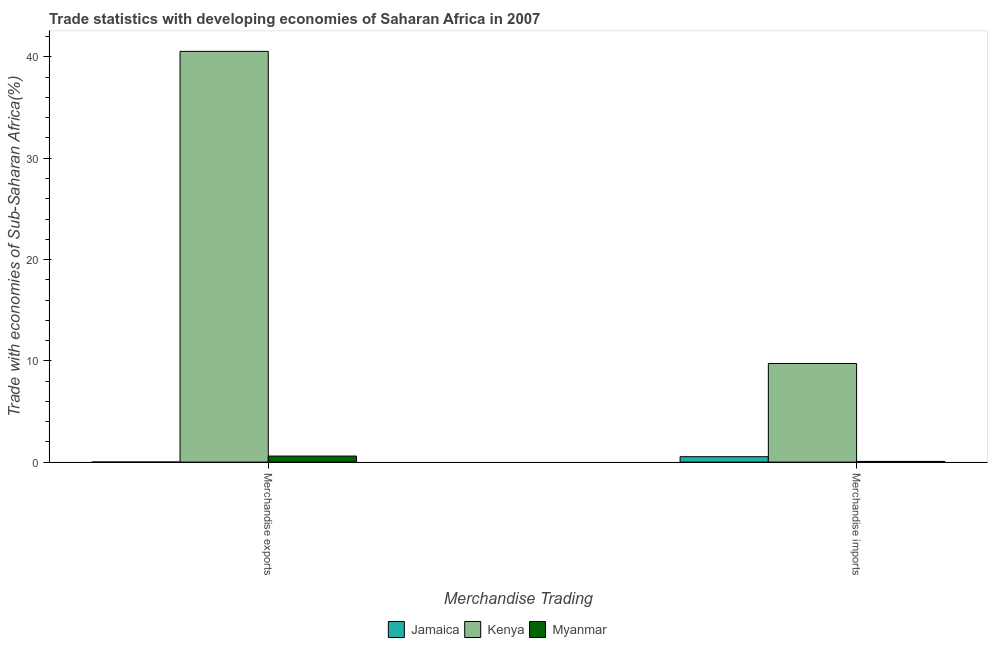How many different coloured bars are there?
Make the answer very short. 3. Are the number of bars per tick equal to the number of legend labels?
Your answer should be very brief. Yes. Are the number of bars on each tick of the X-axis equal?
Offer a very short reply. Yes. How many bars are there on the 1st tick from the left?
Your answer should be compact. 3. How many bars are there on the 1st tick from the right?
Make the answer very short. 3. What is the merchandise imports in Kenya?
Keep it short and to the point. 9.73. Across all countries, what is the maximum merchandise imports?
Offer a terse response. 9.73. Across all countries, what is the minimum merchandise imports?
Provide a succinct answer. 0.07. In which country was the merchandise exports maximum?
Keep it short and to the point. Kenya. In which country was the merchandise imports minimum?
Your response must be concise. Myanmar. What is the total merchandise imports in the graph?
Offer a very short reply. 10.34. What is the difference between the merchandise exports in Kenya and that in Jamaica?
Keep it short and to the point. 40.54. What is the difference between the merchandise exports in Myanmar and the merchandise imports in Jamaica?
Keep it short and to the point. 0.06. What is the average merchandise exports per country?
Keep it short and to the point. 13.72. What is the difference between the merchandise exports and merchandise imports in Jamaica?
Your response must be concise. -0.53. What is the ratio of the merchandise exports in Myanmar to that in Kenya?
Provide a short and direct response. 0.01. Is the merchandise exports in Kenya less than that in Jamaica?
Give a very brief answer. No. In how many countries, is the merchandise imports greater than the average merchandise imports taken over all countries?
Offer a very short reply. 1. What does the 1st bar from the left in Merchandise imports represents?
Provide a succinct answer. Jamaica. What does the 2nd bar from the right in Merchandise exports represents?
Provide a short and direct response. Kenya. Are the values on the major ticks of Y-axis written in scientific E-notation?
Your response must be concise. No. Does the graph contain any zero values?
Your answer should be very brief. No. Does the graph contain grids?
Your response must be concise. No. Where does the legend appear in the graph?
Offer a terse response. Bottom center. What is the title of the graph?
Your answer should be very brief. Trade statistics with developing economies of Saharan Africa in 2007. What is the label or title of the X-axis?
Your answer should be compact. Merchandise Trading. What is the label or title of the Y-axis?
Your response must be concise. Trade with economies of Sub-Saharan Africa(%). What is the Trade with economies of Sub-Saharan Africa(%) of Jamaica in Merchandise exports?
Keep it short and to the point. 0.01. What is the Trade with economies of Sub-Saharan Africa(%) of Kenya in Merchandise exports?
Offer a very short reply. 40.55. What is the Trade with economies of Sub-Saharan Africa(%) in Myanmar in Merchandise exports?
Offer a terse response. 0.6. What is the Trade with economies of Sub-Saharan Africa(%) in Jamaica in Merchandise imports?
Give a very brief answer. 0.54. What is the Trade with economies of Sub-Saharan Africa(%) in Kenya in Merchandise imports?
Offer a terse response. 9.73. What is the Trade with economies of Sub-Saharan Africa(%) of Myanmar in Merchandise imports?
Offer a very short reply. 0.07. Across all Merchandise Trading, what is the maximum Trade with economies of Sub-Saharan Africa(%) in Jamaica?
Give a very brief answer. 0.54. Across all Merchandise Trading, what is the maximum Trade with economies of Sub-Saharan Africa(%) of Kenya?
Your answer should be compact. 40.55. Across all Merchandise Trading, what is the maximum Trade with economies of Sub-Saharan Africa(%) in Myanmar?
Offer a terse response. 0.6. Across all Merchandise Trading, what is the minimum Trade with economies of Sub-Saharan Africa(%) in Jamaica?
Keep it short and to the point. 0.01. Across all Merchandise Trading, what is the minimum Trade with economies of Sub-Saharan Africa(%) in Kenya?
Provide a succinct answer. 9.73. Across all Merchandise Trading, what is the minimum Trade with economies of Sub-Saharan Africa(%) of Myanmar?
Provide a short and direct response. 0.07. What is the total Trade with economies of Sub-Saharan Africa(%) of Jamaica in the graph?
Make the answer very short. 0.54. What is the total Trade with economies of Sub-Saharan Africa(%) of Kenya in the graph?
Your answer should be compact. 50.28. What is the total Trade with economies of Sub-Saharan Africa(%) of Myanmar in the graph?
Your answer should be very brief. 0.67. What is the difference between the Trade with economies of Sub-Saharan Africa(%) of Jamaica in Merchandise exports and that in Merchandise imports?
Your response must be concise. -0.53. What is the difference between the Trade with economies of Sub-Saharan Africa(%) of Kenya in Merchandise exports and that in Merchandise imports?
Offer a terse response. 30.82. What is the difference between the Trade with economies of Sub-Saharan Africa(%) of Myanmar in Merchandise exports and that in Merchandise imports?
Your answer should be compact. 0.53. What is the difference between the Trade with economies of Sub-Saharan Africa(%) in Jamaica in Merchandise exports and the Trade with economies of Sub-Saharan Africa(%) in Kenya in Merchandise imports?
Offer a very short reply. -9.72. What is the difference between the Trade with economies of Sub-Saharan Africa(%) in Jamaica in Merchandise exports and the Trade with economies of Sub-Saharan Africa(%) in Myanmar in Merchandise imports?
Provide a succinct answer. -0.06. What is the difference between the Trade with economies of Sub-Saharan Africa(%) of Kenya in Merchandise exports and the Trade with economies of Sub-Saharan Africa(%) of Myanmar in Merchandise imports?
Ensure brevity in your answer.  40.48. What is the average Trade with economies of Sub-Saharan Africa(%) in Jamaica per Merchandise Trading?
Give a very brief answer. 0.27. What is the average Trade with economies of Sub-Saharan Africa(%) of Kenya per Merchandise Trading?
Your response must be concise. 25.14. What is the average Trade with economies of Sub-Saharan Africa(%) in Myanmar per Merchandise Trading?
Provide a succinct answer. 0.33. What is the difference between the Trade with economies of Sub-Saharan Africa(%) in Jamaica and Trade with economies of Sub-Saharan Africa(%) in Kenya in Merchandise exports?
Keep it short and to the point. -40.54. What is the difference between the Trade with economies of Sub-Saharan Africa(%) of Jamaica and Trade with economies of Sub-Saharan Africa(%) of Myanmar in Merchandise exports?
Your response must be concise. -0.59. What is the difference between the Trade with economies of Sub-Saharan Africa(%) in Kenya and Trade with economies of Sub-Saharan Africa(%) in Myanmar in Merchandise exports?
Your response must be concise. 39.95. What is the difference between the Trade with economies of Sub-Saharan Africa(%) of Jamaica and Trade with economies of Sub-Saharan Africa(%) of Kenya in Merchandise imports?
Provide a succinct answer. -9.2. What is the difference between the Trade with economies of Sub-Saharan Africa(%) in Jamaica and Trade with economies of Sub-Saharan Africa(%) in Myanmar in Merchandise imports?
Provide a succinct answer. 0.46. What is the difference between the Trade with economies of Sub-Saharan Africa(%) in Kenya and Trade with economies of Sub-Saharan Africa(%) in Myanmar in Merchandise imports?
Give a very brief answer. 9.66. What is the ratio of the Trade with economies of Sub-Saharan Africa(%) in Jamaica in Merchandise exports to that in Merchandise imports?
Ensure brevity in your answer.  0.02. What is the ratio of the Trade with economies of Sub-Saharan Africa(%) of Kenya in Merchandise exports to that in Merchandise imports?
Provide a short and direct response. 4.17. What is the ratio of the Trade with economies of Sub-Saharan Africa(%) in Myanmar in Merchandise exports to that in Merchandise imports?
Ensure brevity in your answer.  8.41. What is the difference between the highest and the second highest Trade with economies of Sub-Saharan Africa(%) in Jamaica?
Offer a very short reply. 0.53. What is the difference between the highest and the second highest Trade with economies of Sub-Saharan Africa(%) in Kenya?
Provide a succinct answer. 30.82. What is the difference between the highest and the second highest Trade with economies of Sub-Saharan Africa(%) of Myanmar?
Your answer should be compact. 0.53. What is the difference between the highest and the lowest Trade with economies of Sub-Saharan Africa(%) in Jamaica?
Provide a succinct answer. 0.53. What is the difference between the highest and the lowest Trade with economies of Sub-Saharan Africa(%) of Kenya?
Your answer should be compact. 30.82. What is the difference between the highest and the lowest Trade with economies of Sub-Saharan Africa(%) of Myanmar?
Your response must be concise. 0.53. 